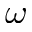Convert formula to latex. <formula><loc_0><loc_0><loc_500><loc_500>\omega</formula> 